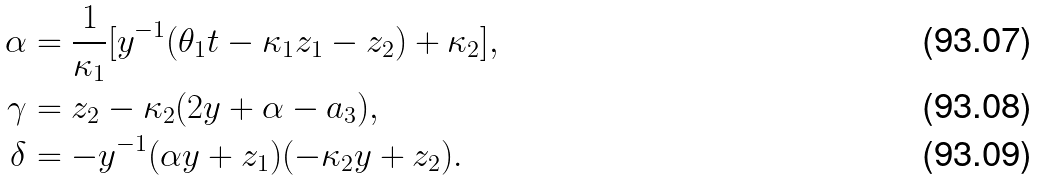Convert formula to latex. <formula><loc_0><loc_0><loc_500><loc_500>\alpha & = \frac { 1 } { \kappa _ { 1 } } [ y ^ { - 1 } ( \theta _ { 1 } t - \kappa _ { 1 } z _ { 1 } - z _ { 2 } ) + \kappa _ { 2 } ] , \\ \gamma & = z _ { 2 } - \kappa _ { 2 } ( 2 y + \alpha - a _ { 3 } ) , \\ \delta & = - y ^ { - 1 } ( \alpha y + z _ { 1 } ) ( - \kappa _ { 2 } y + z _ { 2 } ) .</formula> 